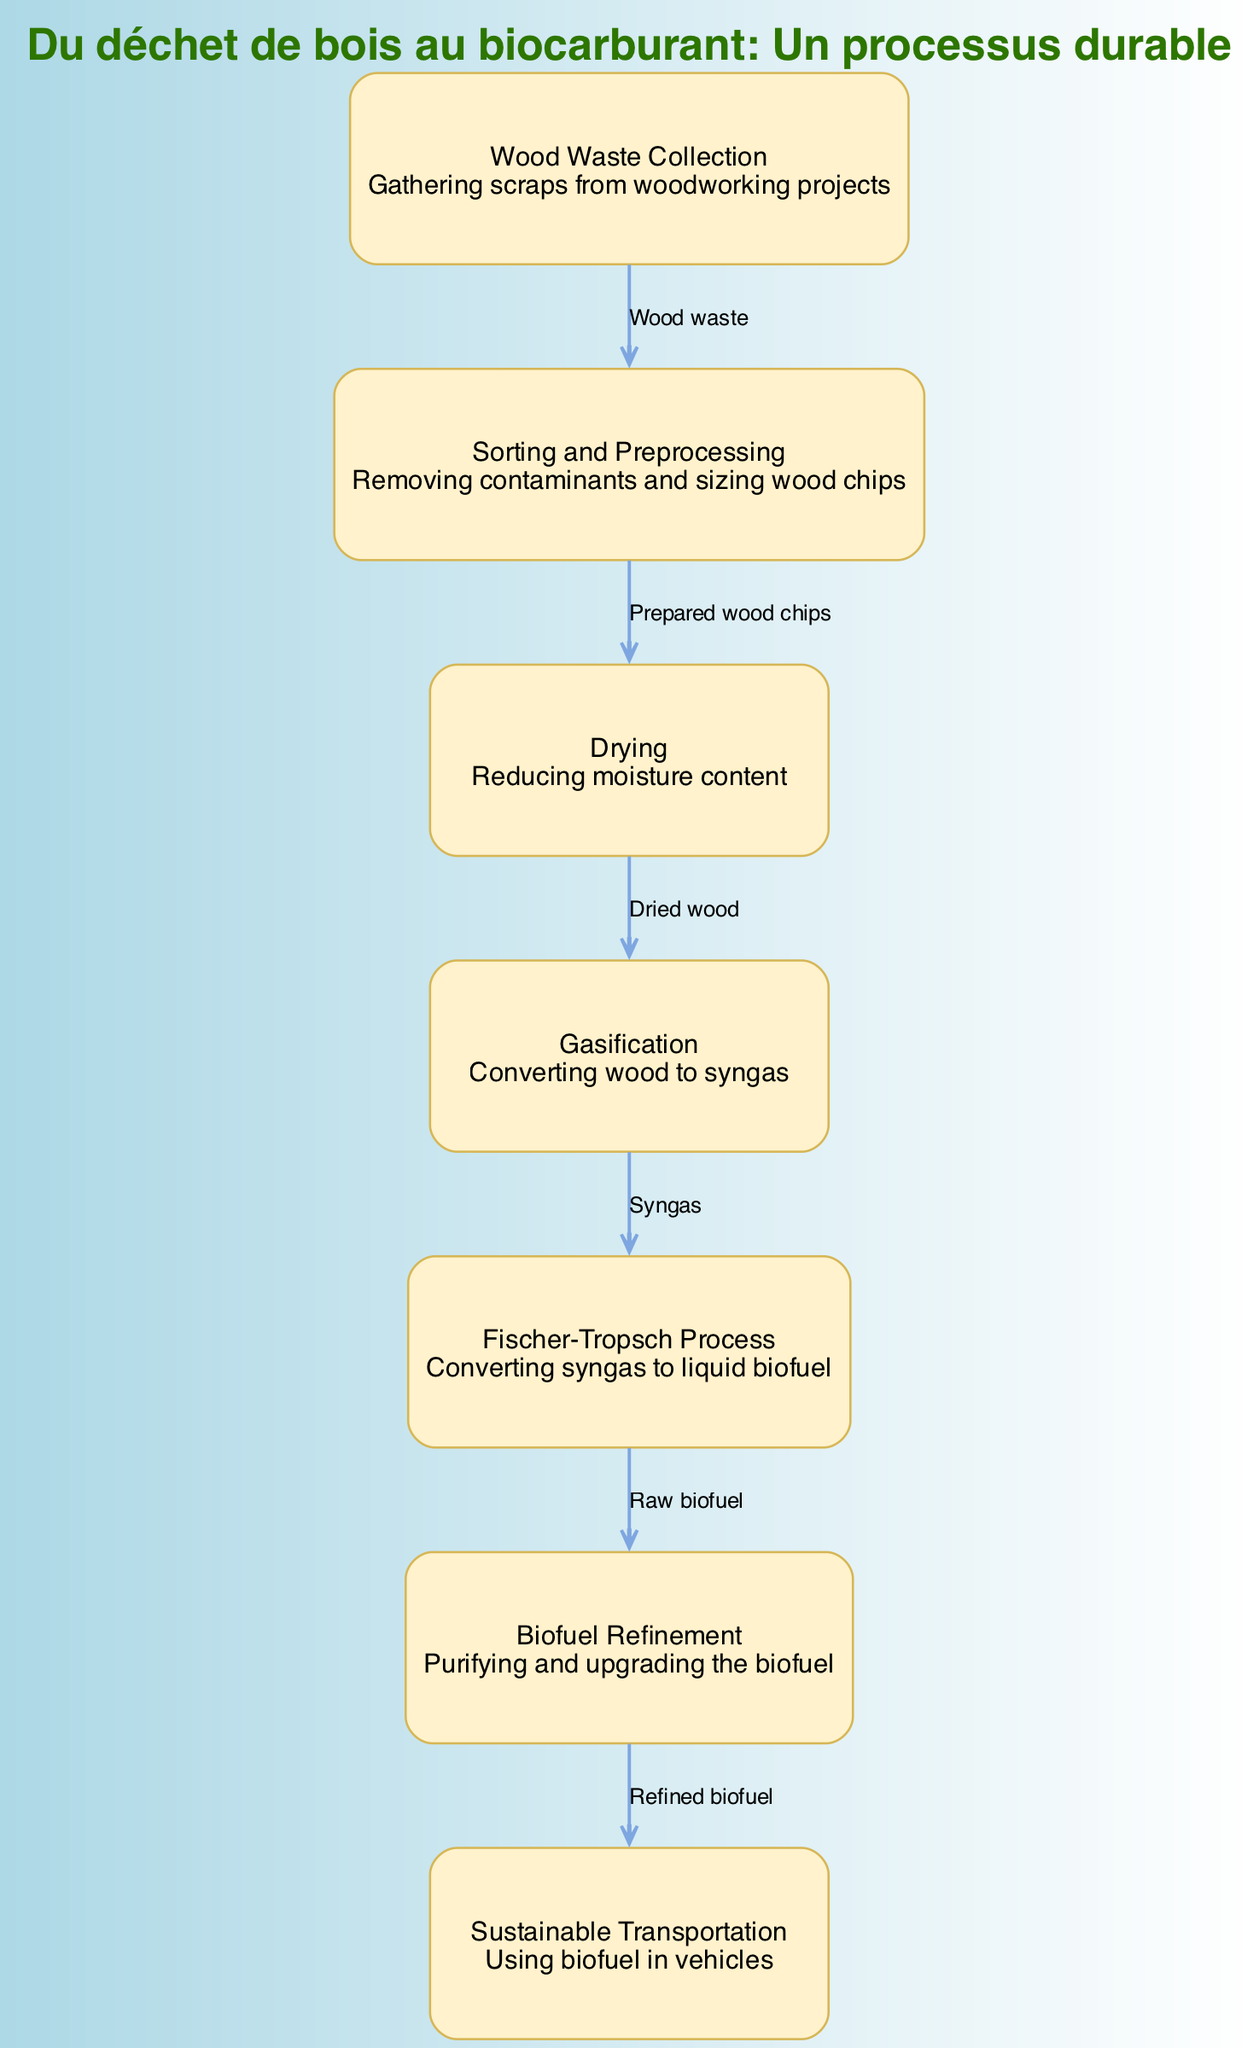What is the first step in the process? The diagram starts with the node labeled "Wood Waste Collection", indicating that gathering scraps is the initial step in converting wood waste into biofuel.
Answer: Wood Waste Collection How many nodes are there in the diagram? By counting the items listed under "nodes", we see there are seven distinct steps in the process from wood waste to biofuel.
Answer: 7 What comes after "Drying"? Following the "Drying" step, the next node in the sequence is "Gasification", which represents the process of converting dried wood into syngas.
Answer: Gasification What type of product is generated from the "Fischer-Tropsch Process"? The "Fischer-Tropsch Process" node depicts conversion of syngas into liquid biofuel, indicating that this process produces raw biofuel as its output.
Answer: Raw biofuel Which step involves removing contaminants? The "Sorting and Preprocessing" step is designated for the removal of contaminants from the collected wood waste and for sizing the wood chips appropriately.
Answer: Sorting and Preprocessing Which two nodes are directly connected by the edge labeled "Prepared wood chips"? The edge labeled "Prepared wood chips" connects the nodes for "Sorting and Preprocessing" and "Drying", indicating the flow from preprocessing to drying.
Answer: Sorting and Preprocessing, Drying What is the last process in the diagram before biofuel is used in vehicles? The final step before the biofuel is used in vehicles is "Biofuel Refinement", which involves purifying and upgrading the biofuel for usage.
Answer: Biofuel Refinement What is converted into syngas during the gasification process? During the gasification process, "Dried wood" is converted into syngas, showcasing the relationship between the drying and gasification steps.
Answer: Dried wood What is the overall title of the diagram? The title associated with the diagram is “Du déchet de bois au biocarburant: Un processus durable” indicating it is about the sustainable process of converting wood waste into biofuel.
Answer: Du déchet de bois au biocarburant: Un processus durable 